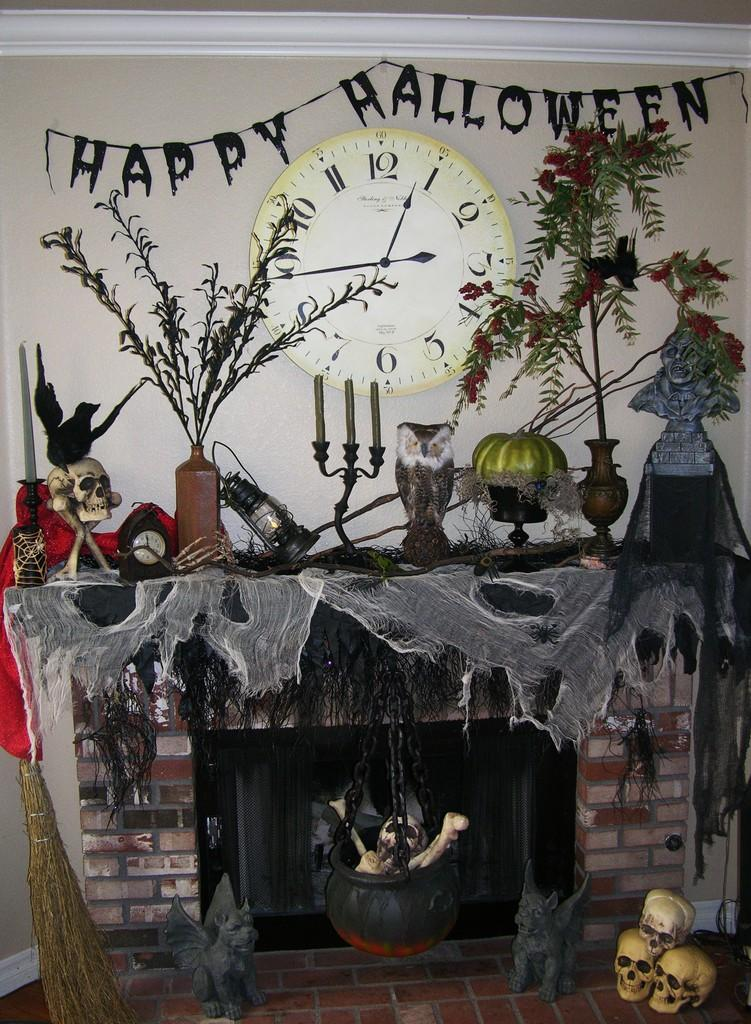Provide a one-sentence caption for the provided image. A fireplace mantle with multiple Halloween decorations and a clock that reads 12:45. 